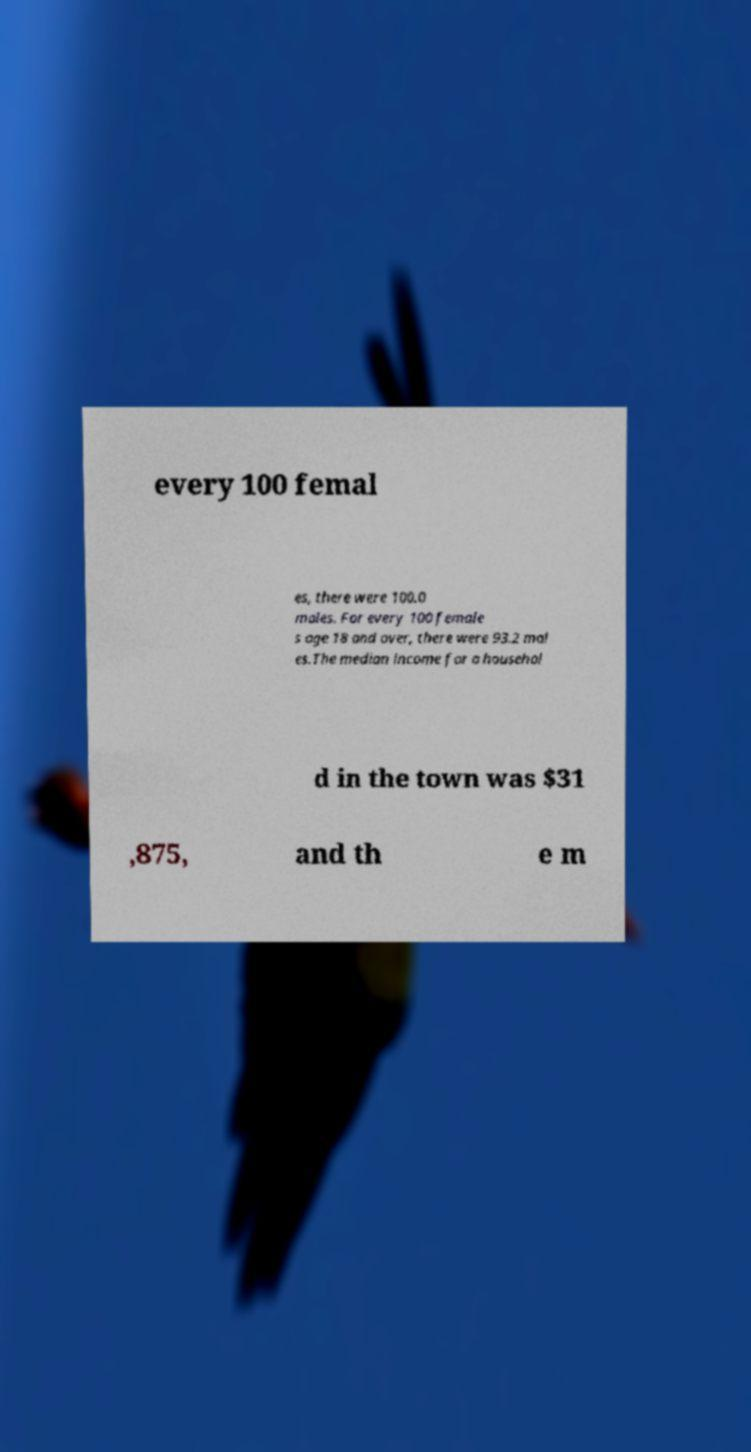Can you accurately transcribe the text from the provided image for me? every 100 femal es, there were 100.0 males. For every 100 female s age 18 and over, there were 93.2 mal es.The median income for a househol d in the town was $31 ,875, and th e m 